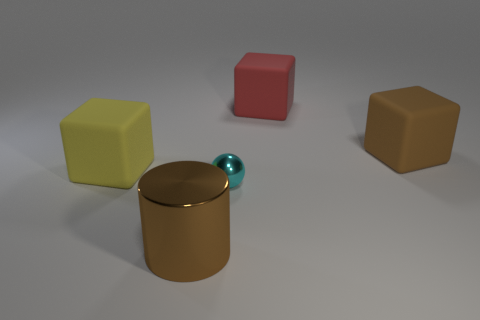Add 4 big red metal cubes. How many objects exist? 9 Subtract all blocks. How many objects are left? 2 Subtract 0 gray balls. How many objects are left? 5 Subtract all large red metallic balls. Subtract all large red matte objects. How many objects are left? 4 Add 2 yellow matte cubes. How many yellow matte cubes are left? 3 Add 5 large brown matte things. How many large brown matte things exist? 6 